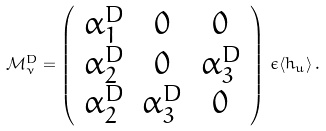Convert formula to latex. <formula><loc_0><loc_0><loc_500><loc_500>\mathcal { M } ^ { D } _ { \nu } = \left ( \begin{array} { c c c } \alpha ^ { D } _ { 1 } & 0 & 0 \\ \alpha ^ { D } _ { 2 } & 0 & \alpha ^ { D } _ { 3 } \\ \alpha ^ { D } _ { 2 } & \alpha ^ { D } _ { 3 } & 0 \end{array} \right ) \, \epsilon \langle h _ { u } \rangle \, .</formula> 